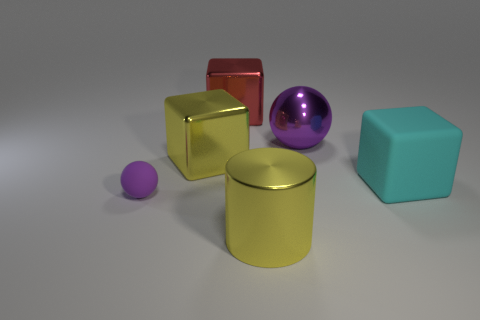Considering the arrangement of objects, what could be a potential purpose for this setup? The arrangement of objects might be intended for a variety of purposes. It could serve as a demonstration of 3D rendering techniques, showcasing different shapes, colors, and material properties, or it may be part of a composition exercise in an art or photography class emphasizing concepts like balance, contrast, and focal points. 